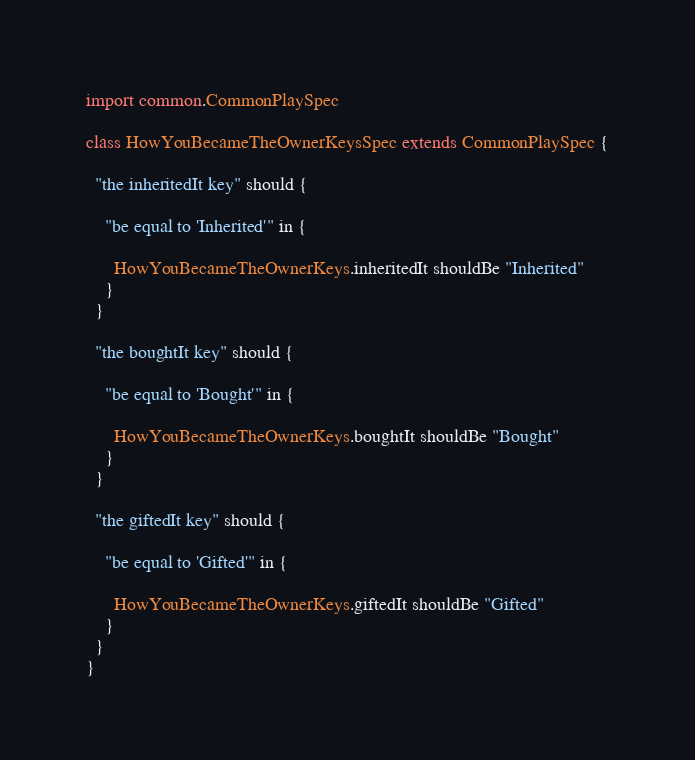Convert code to text. <code><loc_0><loc_0><loc_500><loc_500><_Scala_>
import common.CommonPlaySpec

class HowYouBecameTheOwnerKeysSpec extends CommonPlaySpec {

  "the inheritedIt key" should {

    "be equal to 'Inherited'" in {

      HowYouBecameTheOwnerKeys.inheritedIt shouldBe "Inherited"
    }
  }

  "the boughtIt key" should {

    "be equal to 'Bought'" in {

      HowYouBecameTheOwnerKeys.boughtIt shouldBe "Bought"
    }
  }

  "the giftedIt key" should {

    "be equal to 'Gifted'" in {

      HowYouBecameTheOwnerKeys.giftedIt shouldBe "Gifted"
    }
  }
}
</code> 